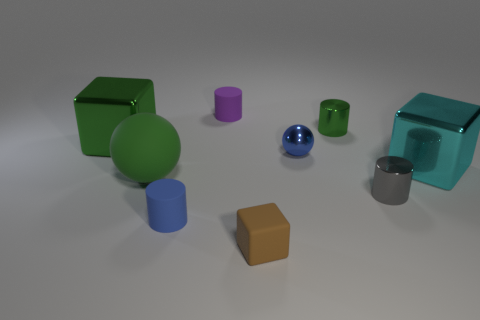Add 1 gray cylinders. How many objects exist? 10 Subtract all cylinders. How many objects are left? 5 Add 1 large gray objects. How many large gray objects exist? 1 Subtract 0 blue blocks. How many objects are left? 9 Subtract all large objects. Subtract all green metal cubes. How many objects are left? 5 Add 2 brown things. How many brown things are left? 3 